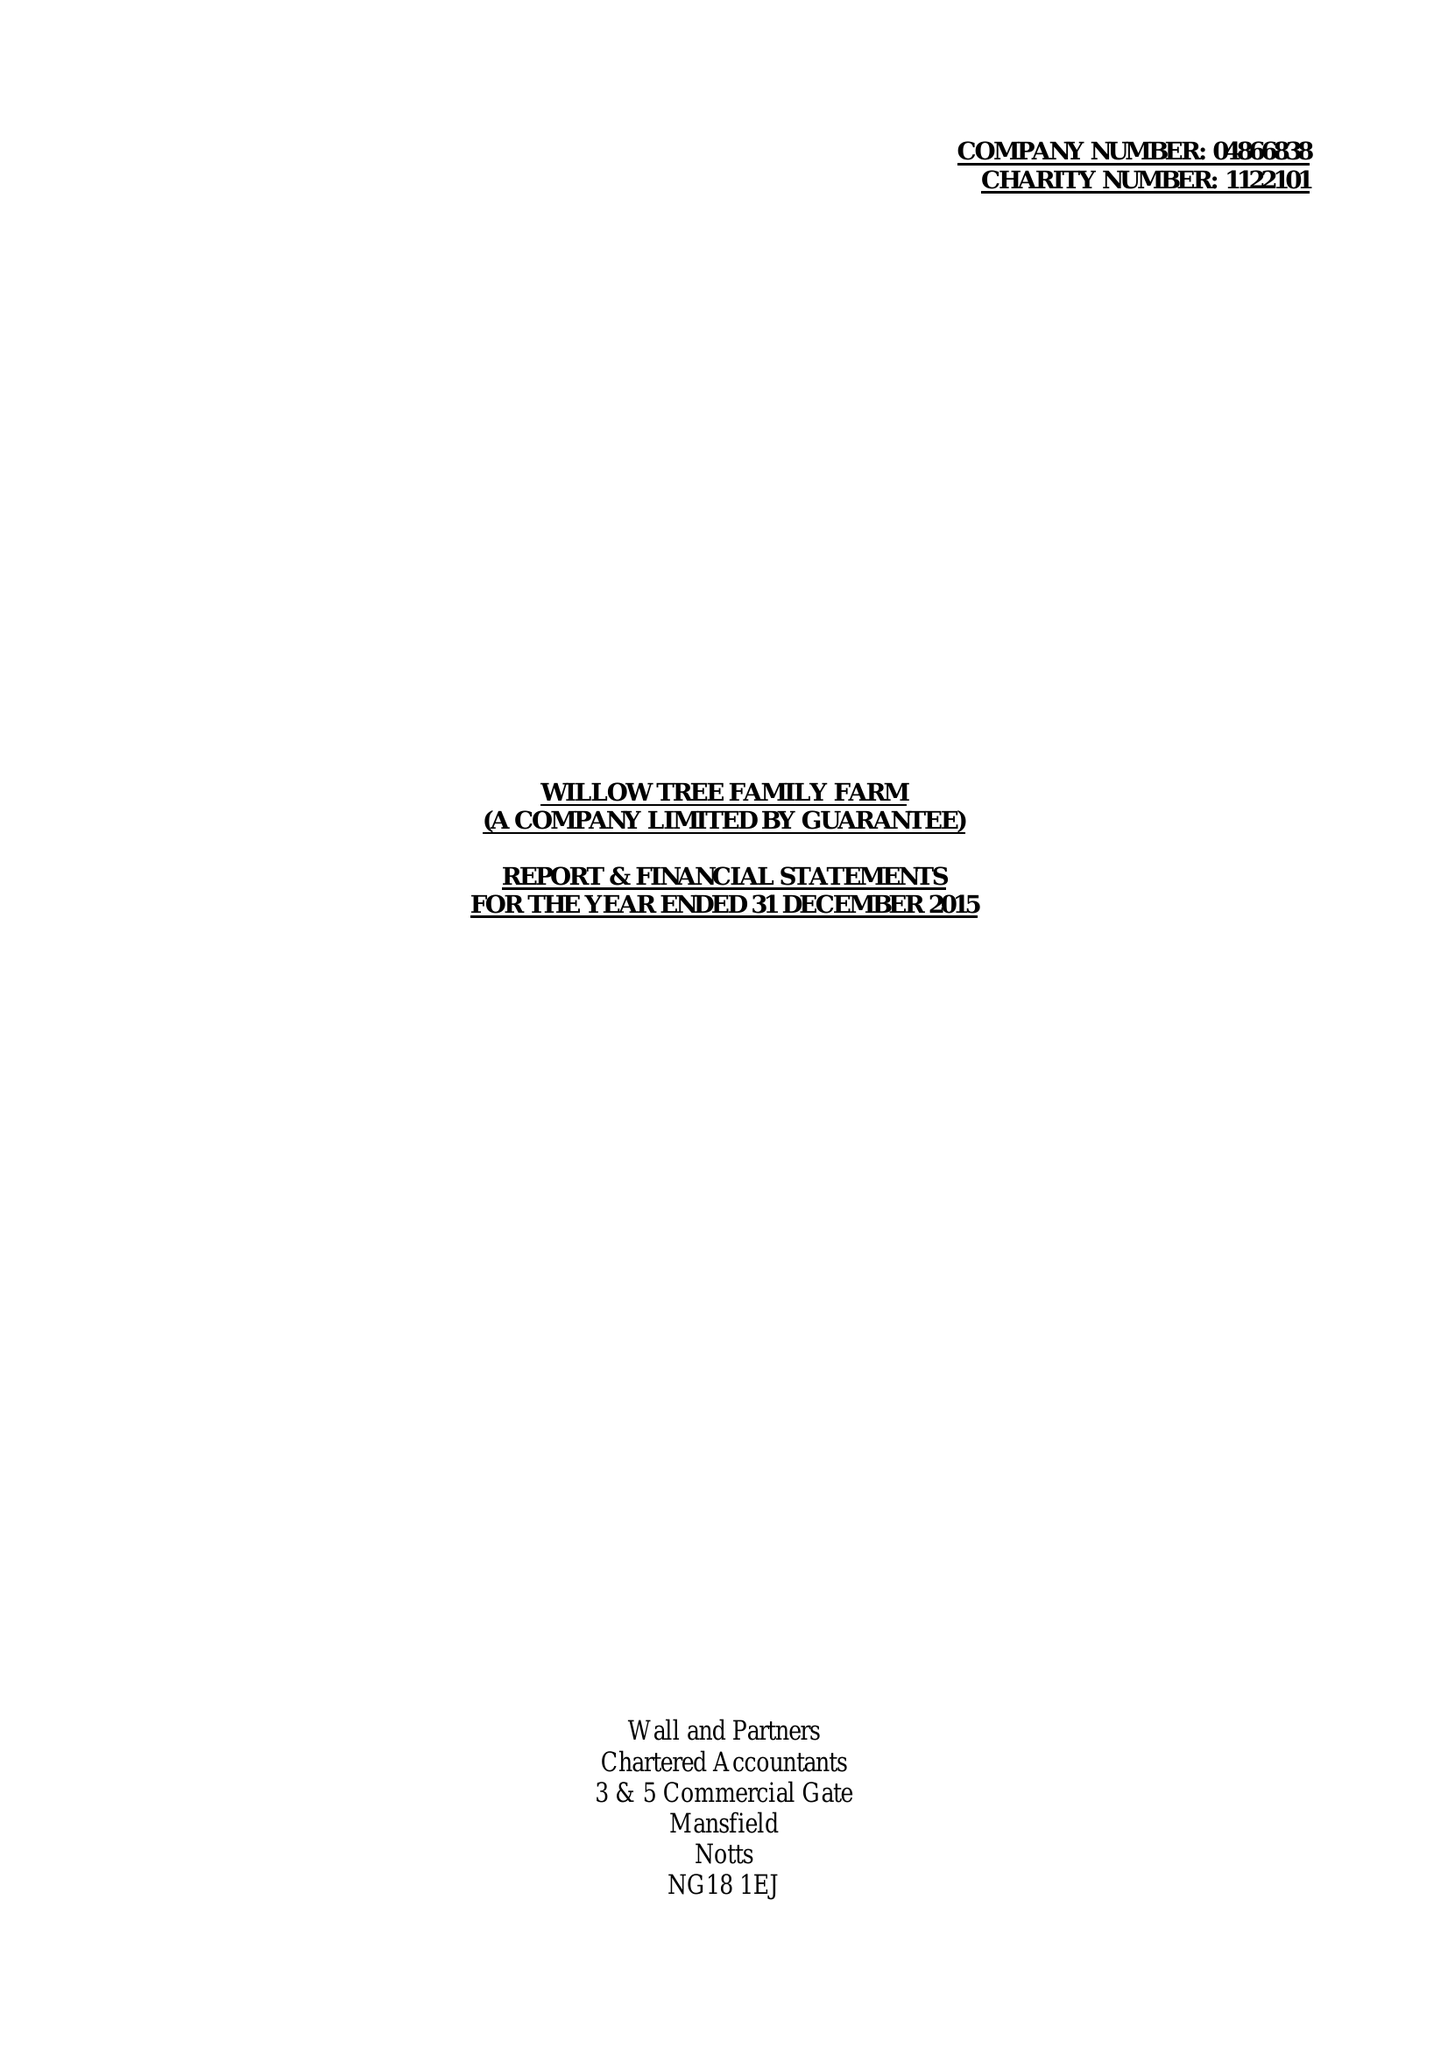What is the value for the charity_number?
Answer the question using a single word or phrase. 1122101 